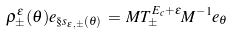<formula> <loc_0><loc_0><loc_500><loc_500>\rho _ { \pm } ^ { \epsilon } ( \theta ) e _ { \S s _ { \epsilon , \pm } ( \theta ) } \, = \, M T ^ { E _ { c } + \epsilon } _ { \pm } M ^ { - 1 } e _ { \theta }</formula> 